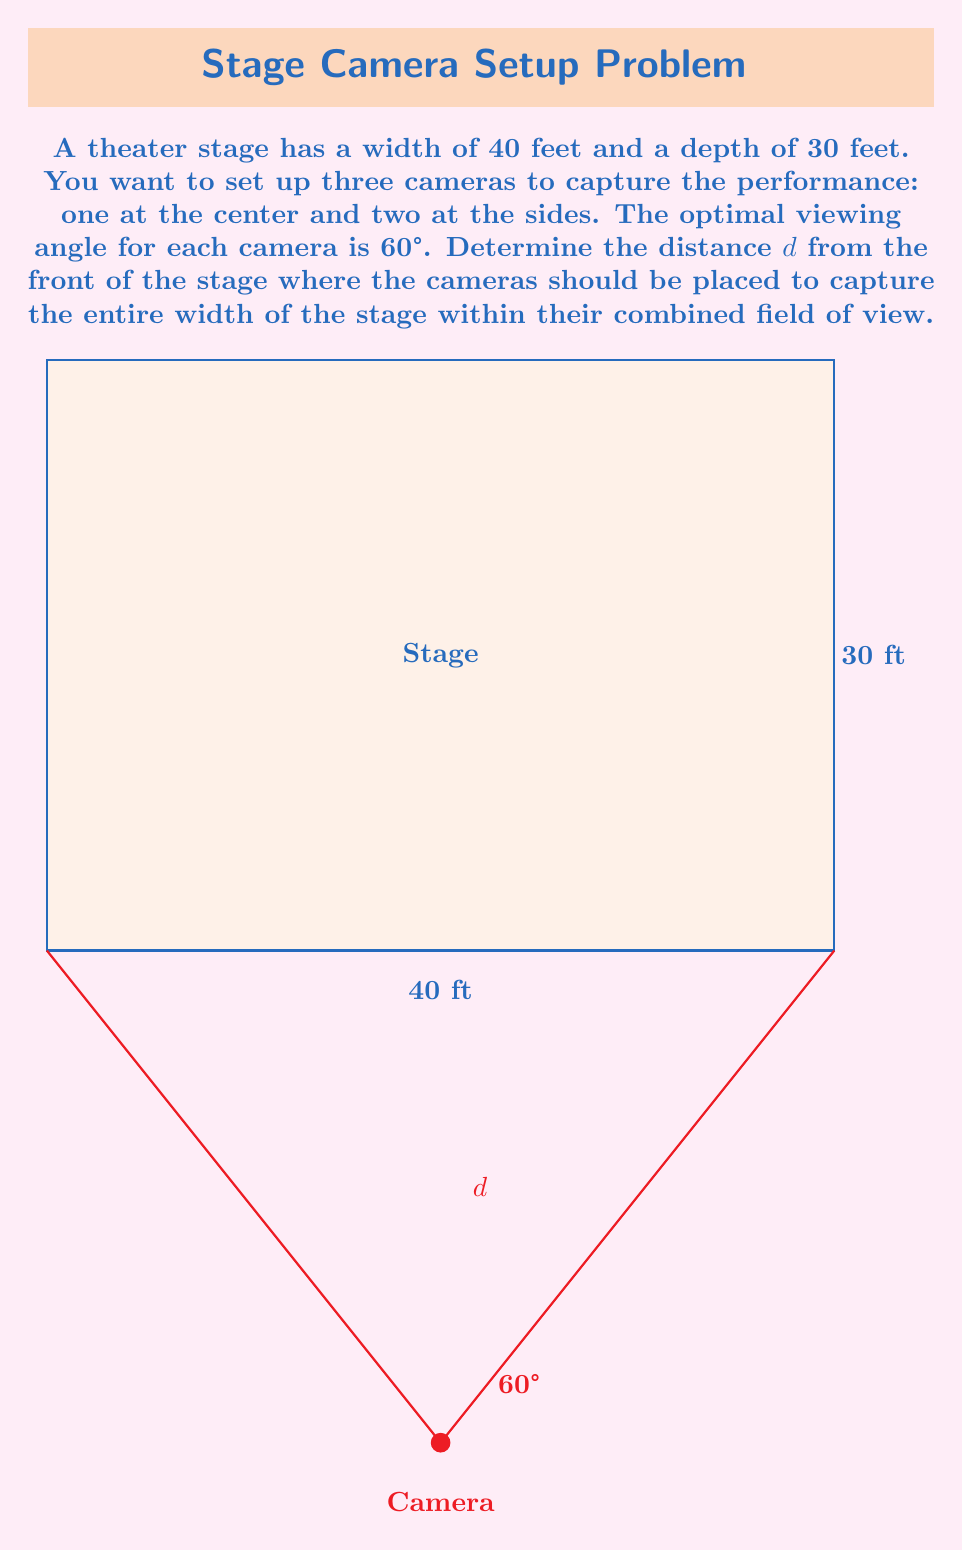Can you answer this question? Let's approach this step-by-step:

1) First, we need to understand that the three cameras should cover the entire width of the stage. The center camera will be placed directly in front of the stage, while the two side cameras will be angled inwards.

2) Given that the optimal viewing angle is 60°, we can split this into two 30° angles on either side of the center line for each camera.

3) We can now use trigonometry to solve this problem. We'll focus on one half of the stage, as it's symmetrical.

4) Let's consider a right triangle formed by:
   - The half-width of the stage (20 feet)
   - The distance $d$ we're trying to find
   - The line of sight of the camera at a 30° angle

5) In this triangle, we know:
   - The opposite side is 20 feet (half the stage width)
   - The angle is 30°
   - We need to find the adjacent side (d)

6) We can use the tangent function:

   $$\tan(30°) = \frac{\text{opposite}}{\text{adjacent}} = \frac{20}{d}$$

7) We know that $\tan(30°) = \frac{1}{\sqrt{3}}$, so:

   $$\frac{1}{\sqrt{3}} = \frac{20}{d}$$

8) Cross-multiplying:

   $$d = 20\sqrt{3}$$

9) Therefore, the cameras should be placed at a distance of $20\sqrt{3}$ feet from the front of the stage.
Answer: $20\sqrt{3}$ feet 